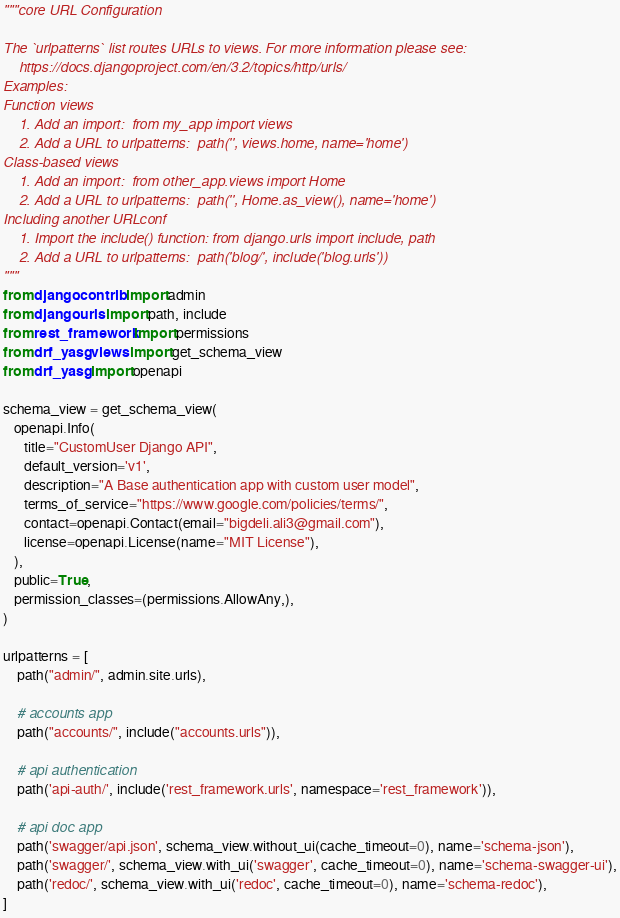<code> <loc_0><loc_0><loc_500><loc_500><_Python_>"""core URL Configuration

The `urlpatterns` list routes URLs to views. For more information please see:
    https://docs.djangoproject.com/en/3.2/topics/http/urls/
Examples:
Function views
    1. Add an import:  from my_app import views
    2. Add a URL to urlpatterns:  path('', views.home, name='home')
Class-based views
    1. Add an import:  from other_app.views import Home
    2. Add a URL to urlpatterns:  path('', Home.as_view(), name='home')
Including another URLconf
    1. Import the include() function: from django.urls import include, path
    2. Add a URL to urlpatterns:  path('blog/', include('blog.urls'))
"""
from django.contrib import admin
from django.urls import path, include
from rest_framework import permissions
from drf_yasg.views import get_schema_view
from drf_yasg import openapi

schema_view = get_schema_view(
   openapi.Info(
      title="CustomUser Django API",
      default_version='v1',
      description="A Base authentication app with custom user model",
      terms_of_service="https://www.google.com/policies/terms/",
      contact=openapi.Contact(email="bigdeli.ali3@gmail.com"),
      license=openapi.License(name="MIT License"),
   ),
   public=True,
   permission_classes=(permissions.AllowAny,),
)

urlpatterns = [
    path("admin/", admin.site.urls),
    
    # accounts app
    path("accounts/", include("accounts.urls")),

    # api authentication 
    path('api-auth/', include('rest_framework.urls', namespace='rest_framework')),

    # api doc app
    path('swagger/api.json', schema_view.without_ui(cache_timeout=0), name='schema-json'),
    path('swagger/', schema_view.with_ui('swagger', cache_timeout=0), name='schema-swagger-ui'),
    path('redoc/', schema_view.with_ui('redoc', cache_timeout=0), name='schema-redoc'),
]
</code> 